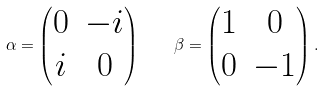<formula> <loc_0><loc_0><loc_500><loc_500>\alpha = \begin{pmatrix} 0 & - i \\ i & 0 \end{pmatrix} \quad \beta = \begin{pmatrix} 1 & 0 \\ 0 & - 1 \end{pmatrix} .</formula> 